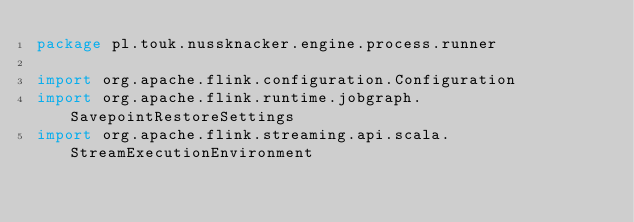<code> <loc_0><loc_0><loc_500><loc_500><_Scala_>package pl.touk.nussknacker.engine.process.runner

import org.apache.flink.configuration.Configuration
import org.apache.flink.runtime.jobgraph.SavepointRestoreSettings
import org.apache.flink.streaming.api.scala.StreamExecutionEnvironment</code> 